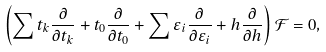<formula> <loc_0><loc_0><loc_500><loc_500>\left ( \sum t _ { k } \frac { \partial } { \partial t _ { k } } + t _ { 0 } \frac { \partial } { \partial t _ { 0 } } + \sum \varepsilon _ { i } \frac { \partial } { \partial \varepsilon _ { i } } + h \frac { \partial } { \partial h } \right ) \mathcal { F } = 0 ,</formula> 